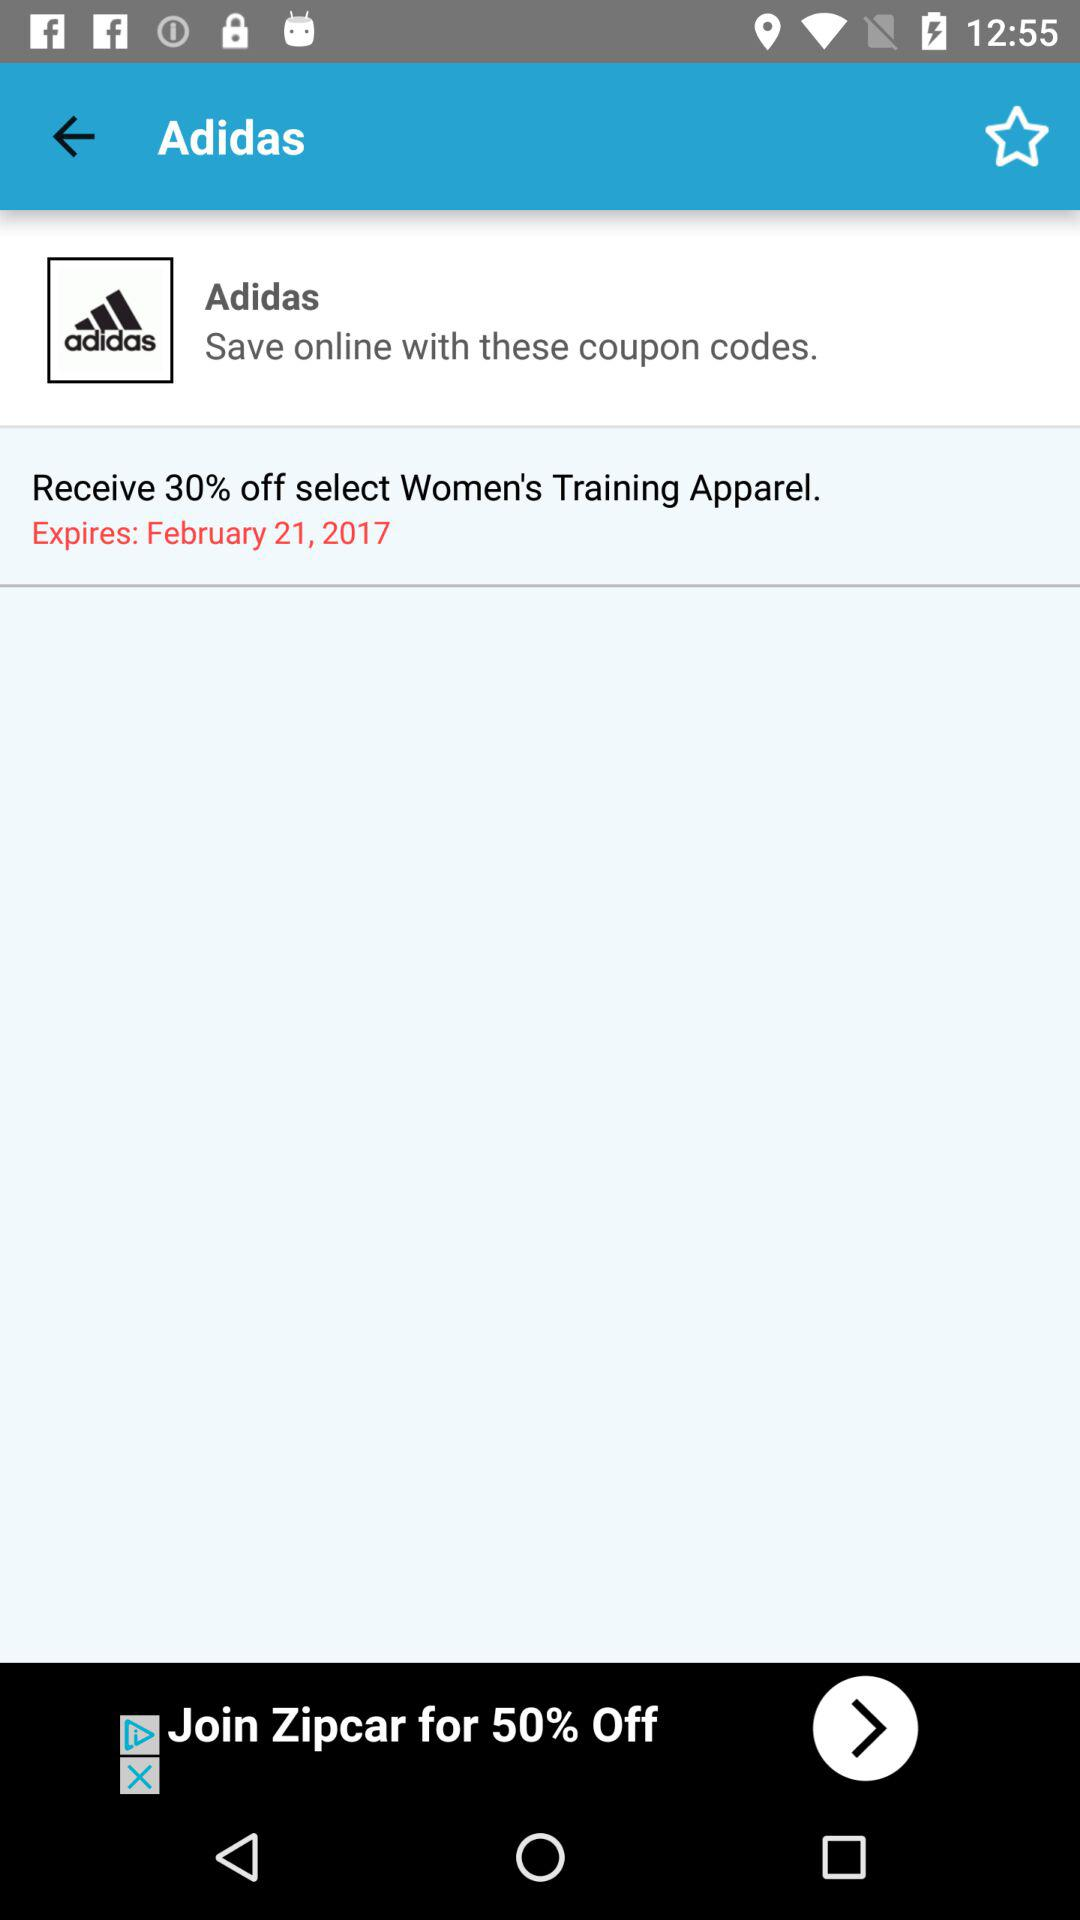How much discount is there on women's training apparel? The discount is 30% off. 